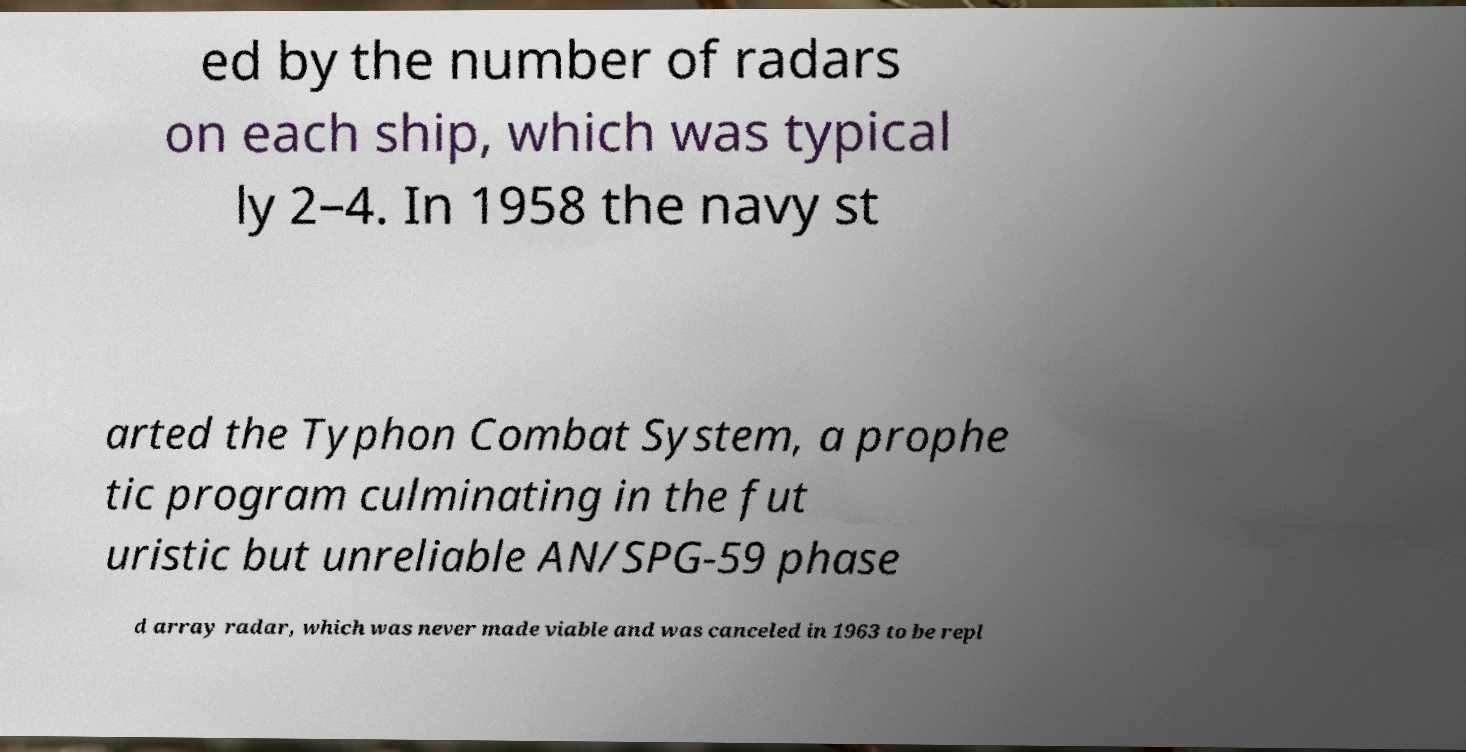Please read and relay the text visible in this image. What does it say? ed by the number of radars on each ship, which was typical ly 2–4. In 1958 the navy st arted the Typhon Combat System, a prophe tic program culminating in the fut uristic but unreliable AN/SPG-59 phase d array radar, which was never made viable and was canceled in 1963 to be repl 